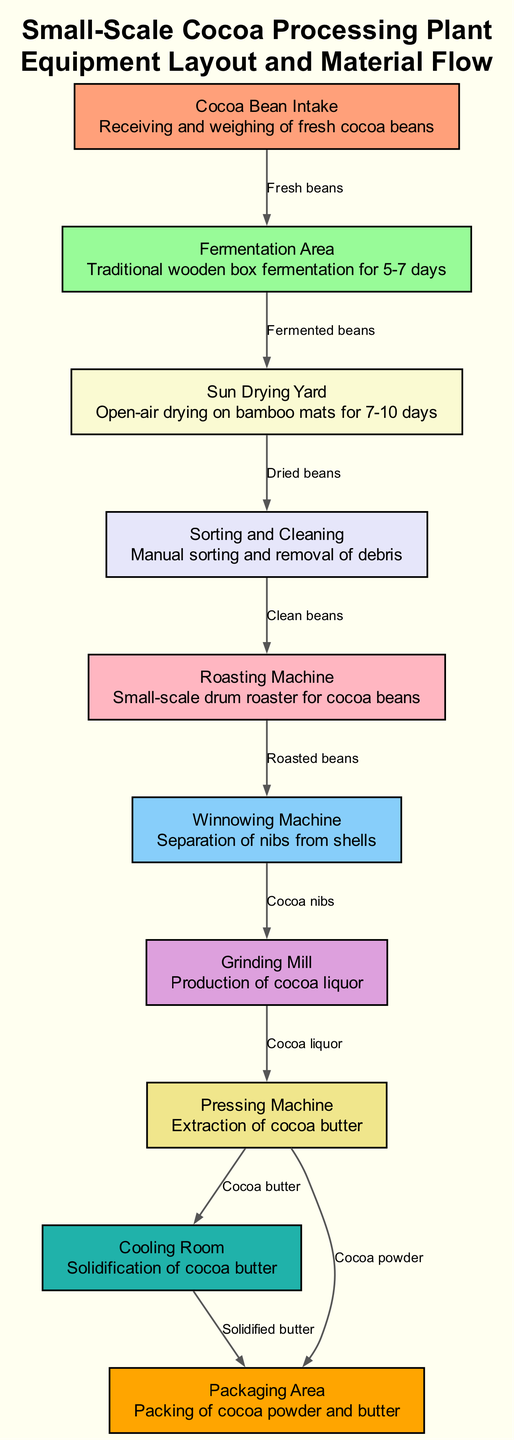What is the first step in the cocoa processing plant? The first step is "Cocoa Bean Intake," where fresh cocoa beans are received and weighed.
Answer: Cocoa Bean Intake How many nodes are there in the diagram? There are 10 nodes, representing different stages in the cocoa processing.
Answer: 10 What are the materials that flow from the Roasting Machine? From the Roasting Machine, the materials that flow are "Cocoa nibs."
Answer: Cocoa nibs What is the purpose of the Pressing Machine? The Pressing Machine is used for the extraction of cocoa butter.
Answer: Extraction of cocoa butter What follows after the Sorting and Cleaning step? After Sorting and Cleaning, the next step is "Roasting Machine," where clean beans are roasted.
Answer: Roasting Machine Which two nodes are directly connected by the edge labeled "Cocoa liquor"? The nodes connected by this edge are "Grinding Mill" and "Pressing Machine."
Answer: Grinding Mill and Pressing Machine What is the final product packaged in the Packaging Area? The Packaging Area is responsible for packing cocoa powder and butter.
Answer: Cocoa powder and butter What is the intermediate step that follows Sun Drying Yard? The intermediate step that follows is "Sorting and Cleaning," where dried beans are sorted and cleaned.
Answer: Sorting and Cleaning From which step do the dried beans come? Dried beans come from the "Sun Drying Yard" after the drying process.
Answer: Sun Drying Yard 